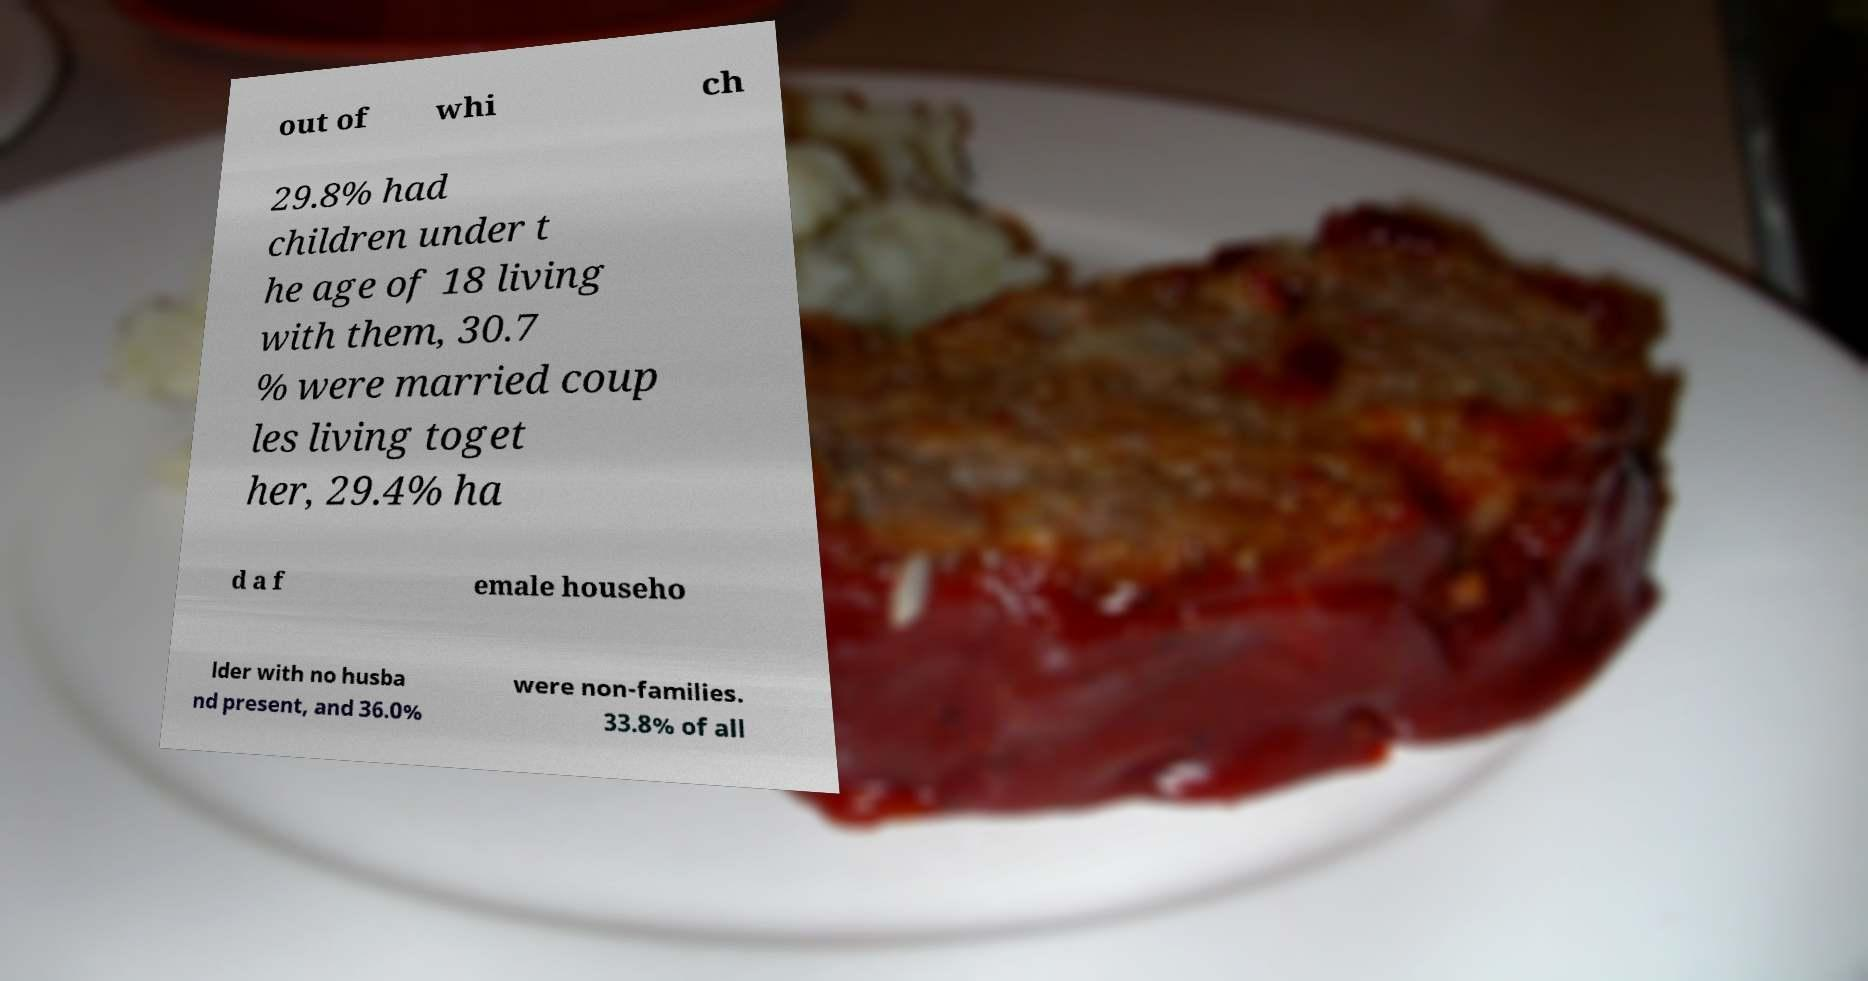Can you read and provide the text displayed in the image?This photo seems to have some interesting text. Can you extract and type it out for me? out of whi ch 29.8% had children under t he age of 18 living with them, 30.7 % were married coup les living toget her, 29.4% ha d a f emale househo lder with no husba nd present, and 36.0% were non-families. 33.8% of all 